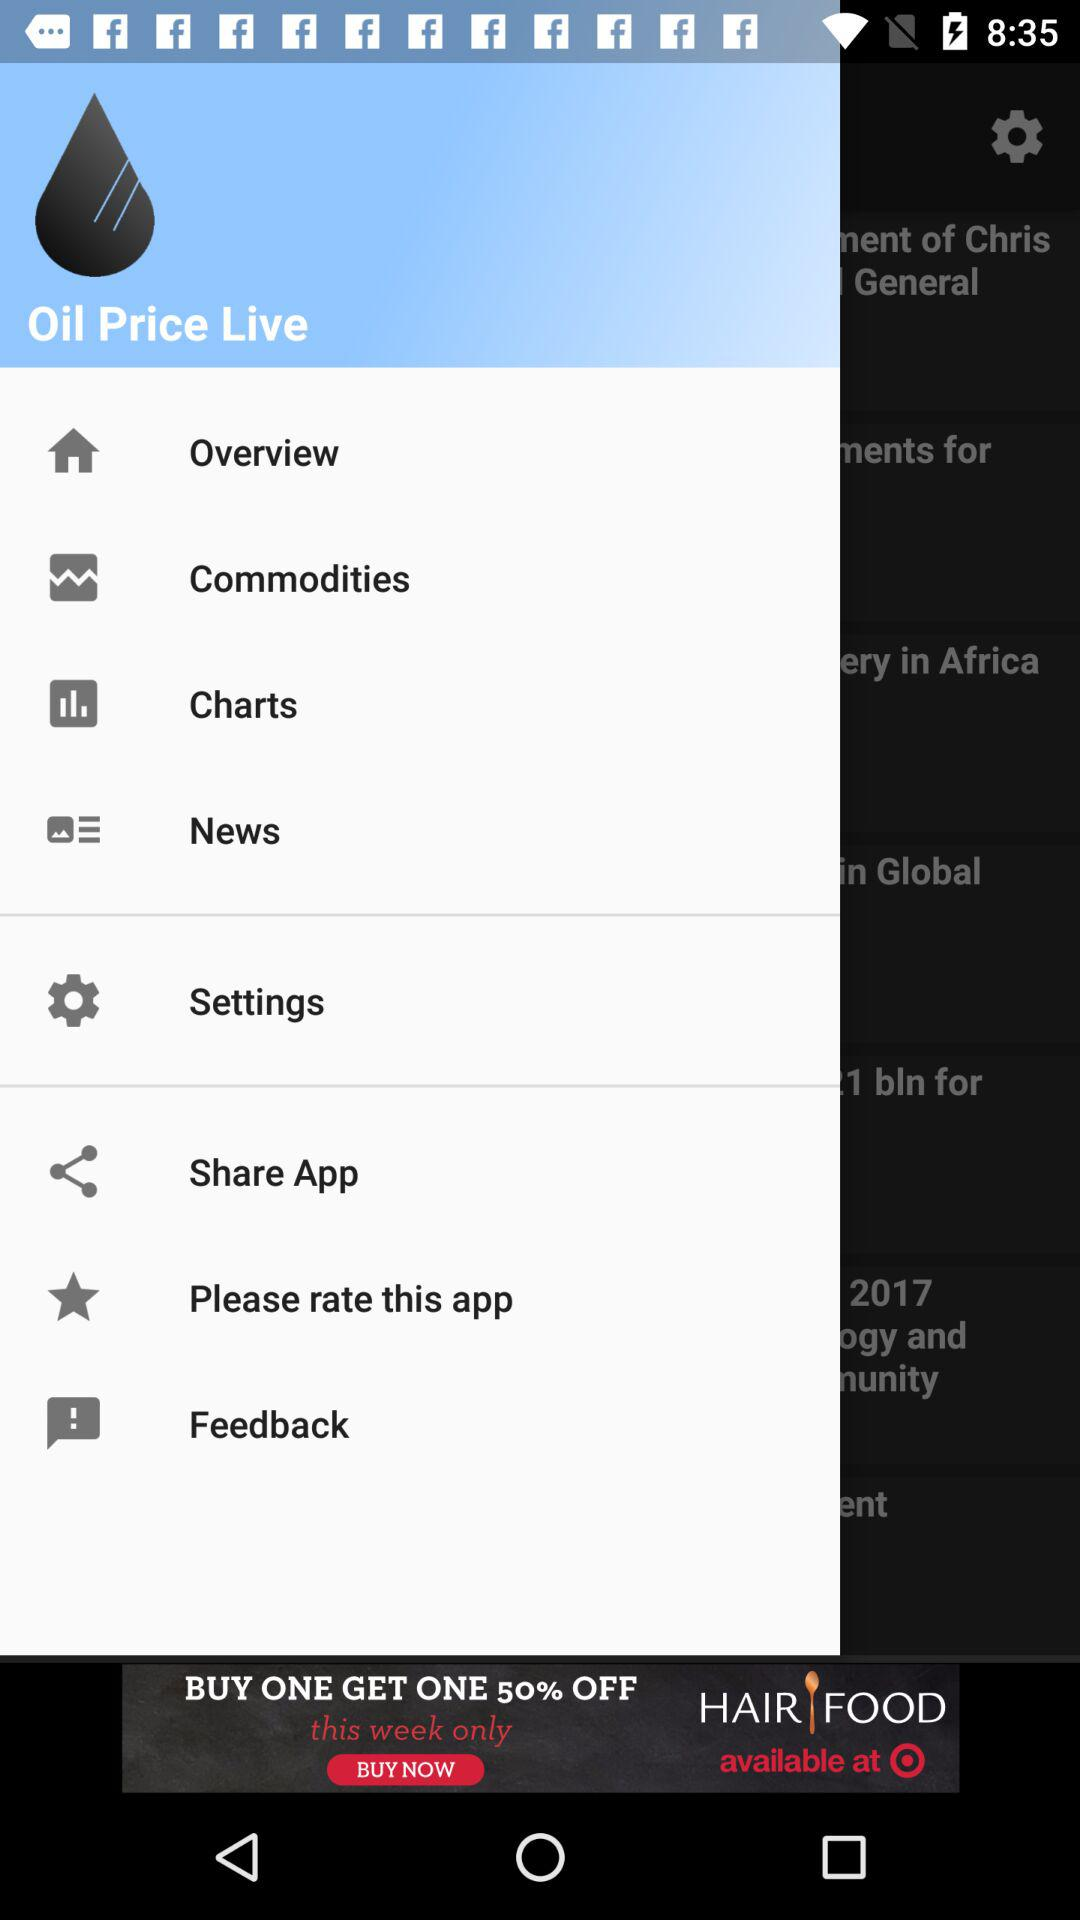What is the application name? The name of the application is "Oil Price Live". 